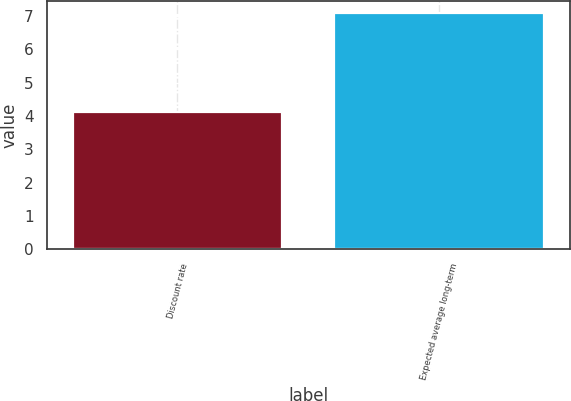Convert chart. <chart><loc_0><loc_0><loc_500><loc_500><bar_chart><fcel>Discount rate<fcel>Expected average long-term<nl><fcel>4.11<fcel>7.09<nl></chart> 